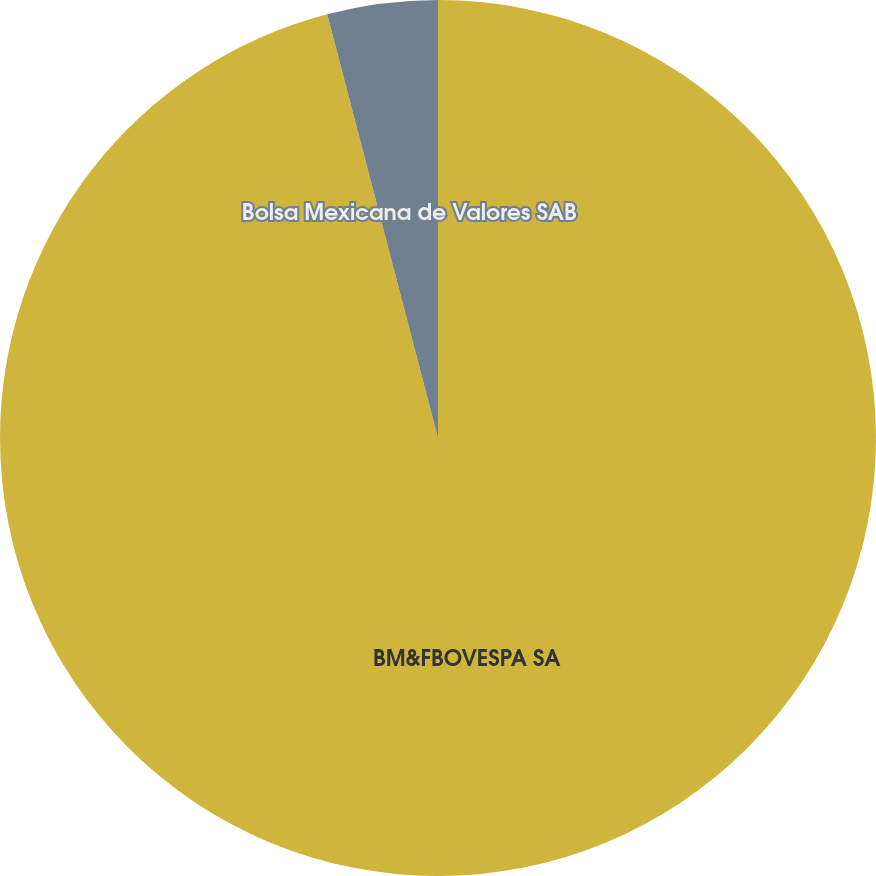<chart> <loc_0><loc_0><loc_500><loc_500><pie_chart><fcel>BM&FBOVESPA SA<fcel>Bolsa Mexicana de Valores SAB<nl><fcel>95.93%<fcel>4.07%<nl></chart> 